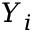<formula> <loc_0><loc_0><loc_500><loc_500>Y _ { i }</formula> 